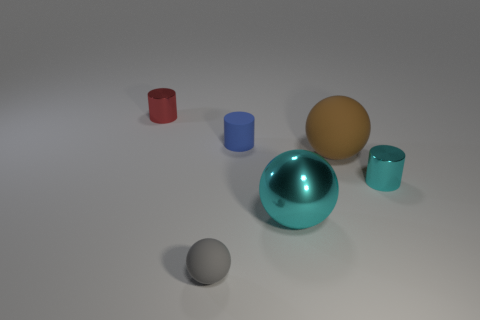Add 3 cyan metallic cylinders. How many objects exist? 9 Subtract all green cylinders. Subtract all brown blocks. How many cylinders are left? 3 Add 6 gray rubber objects. How many gray rubber objects are left? 7 Add 3 red metal cubes. How many red metal cubes exist? 3 Subtract 1 blue cylinders. How many objects are left? 5 Subtract all large green metal cylinders. Subtract all brown objects. How many objects are left? 5 